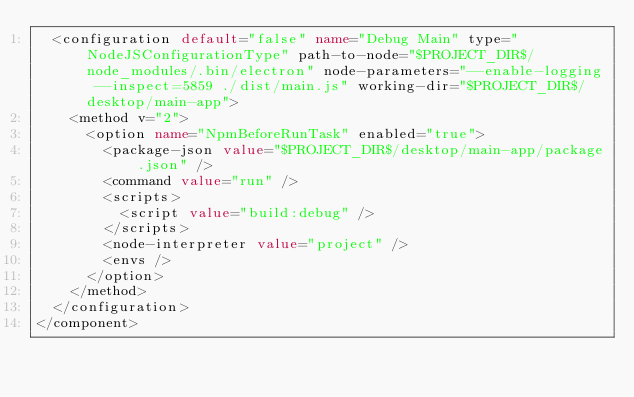Convert code to text. <code><loc_0><loc_0><loc_500><loc_500><_XML_>  <configuration default="false" name="Debug Main" type="NodeJSConfigurationType" path-to-node="$PROJECT_DIR$/node_modules/.bin/electron" node-parameters="--enable-logging --inspect=5859 ./dist/main.js" working-dir="$PROJECT_DIR$/desktop/main-app">
    <method v="2">
      <option name="NpmBeforeRunTask" enabled="true">
        <package-json value="$PROJECT_DIR$/desktop/main-app/package.json" />
        <command value="run" />
        <scripts>
          <script value="build:debug" />
        </scripts>
        <node-interpreter value="project" />
        <envs />
      </option>
    </method>
  </configuration>
</component></code> 